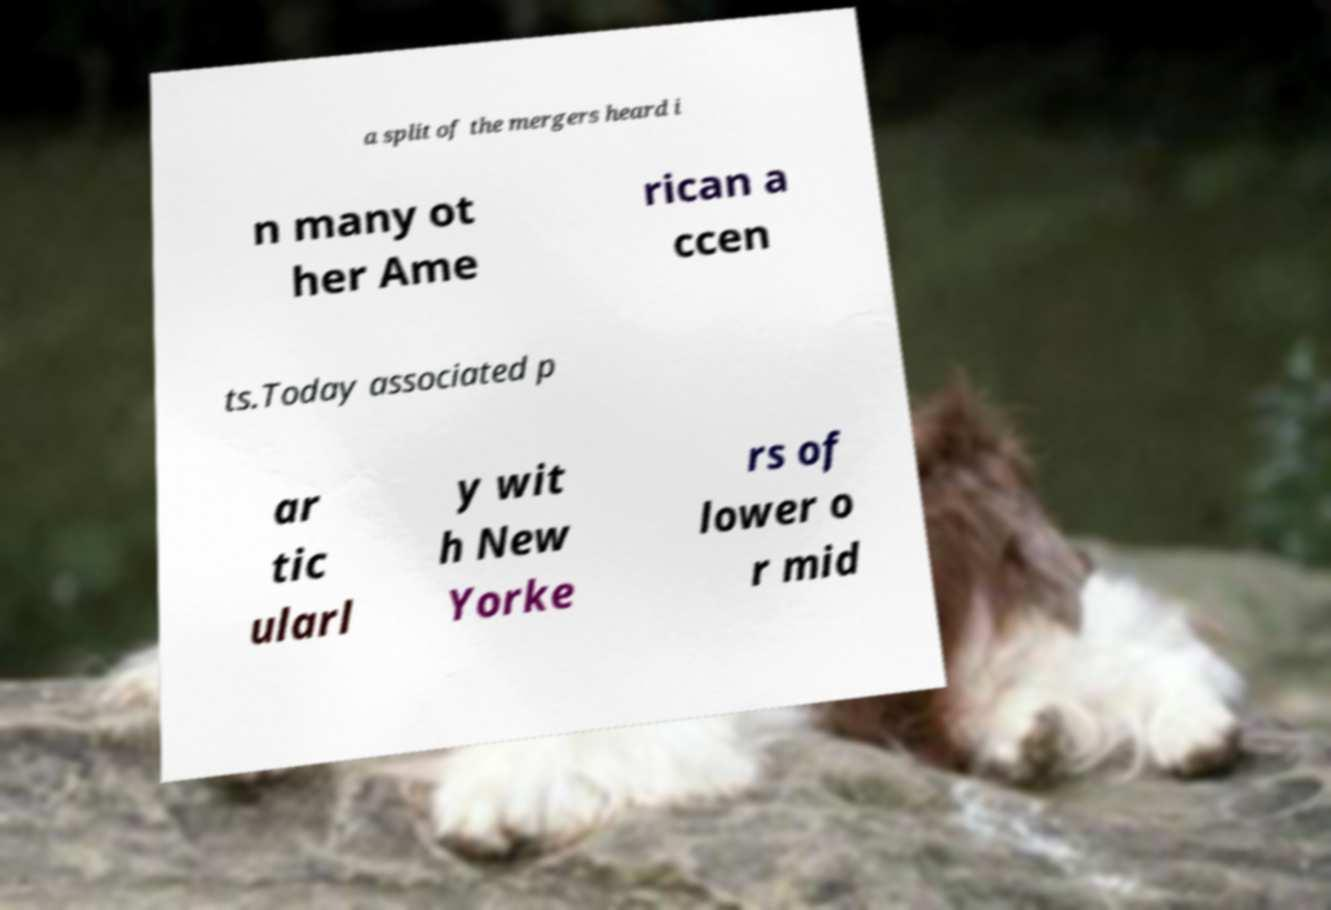Could you extract and type out the text from this image? a split of the mergers heard i n many ot her Ame rican a ccen ts.Today associated p ar tic ularl y wit h New Yorke rs of lower o r mid 